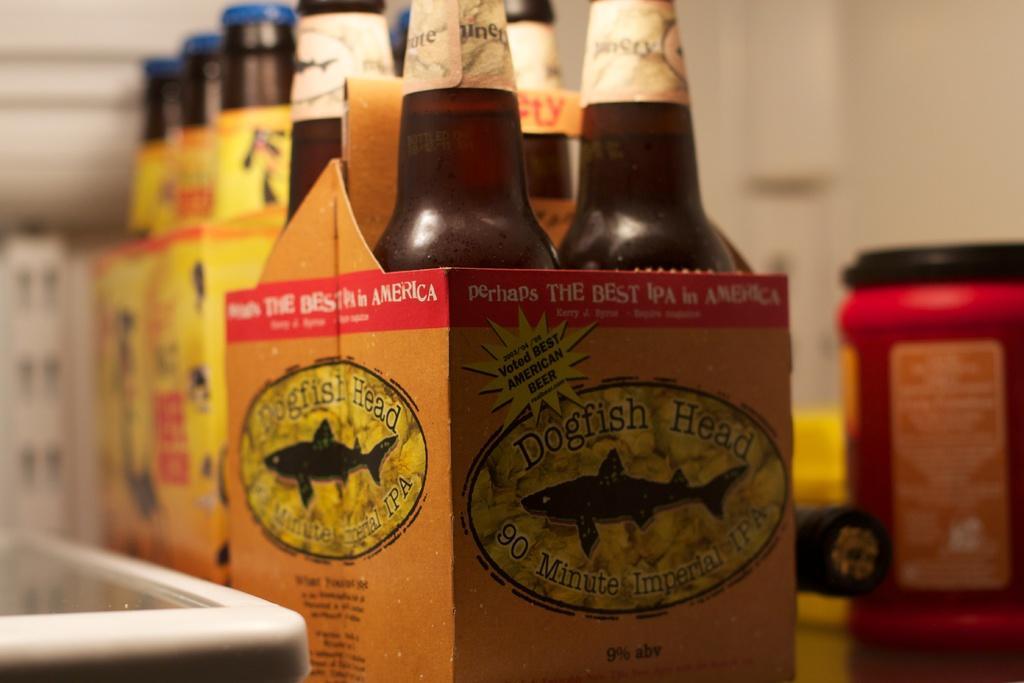In one or two sentences, can you explain what this image depicts? In this image, we can see bottles in the boxes and in the background, there is a jar and we can see some other objects and we can see a wall. 